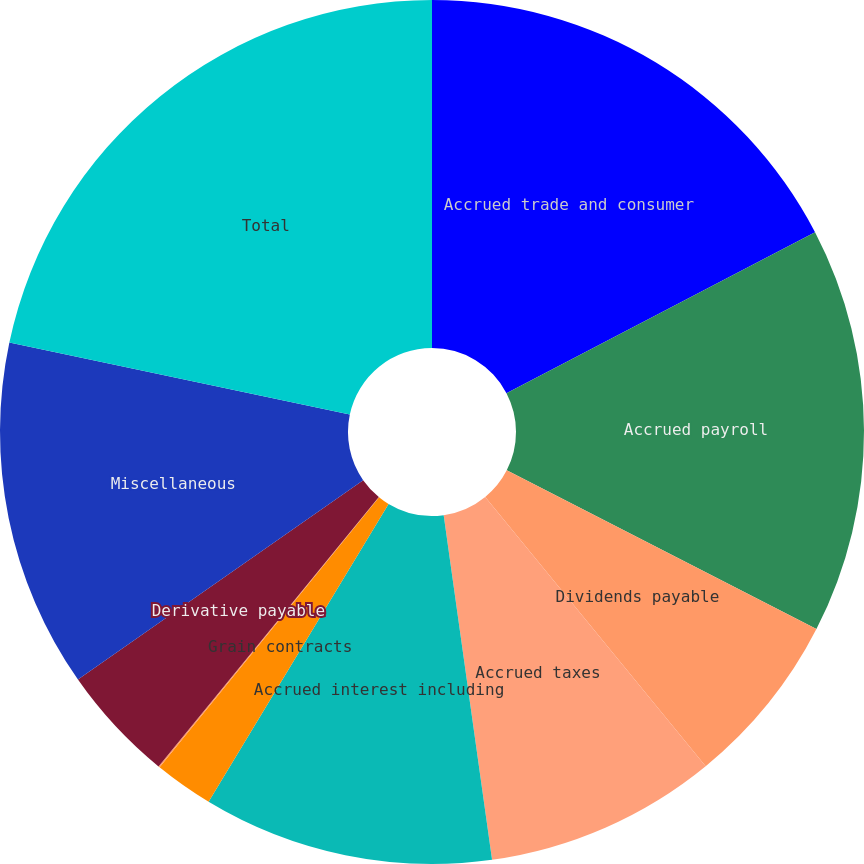Convert chart. <chart><loc_0><loc_0><loc_500><loc_500><pie_chart><fcel>Accrued trade and consumer<fcel>Accrued payroll<fcel>Dividends payable<fcel>Accrued taxes<fcel>Accrued interest including<fcel>Grain contracts<fcel>Restructuring and other exit<fcel>Derivative payable<fcel>Miscellaneous<fcel>Total<nl><fcel>17.35%<fcel>15.19%<fcel>6.54%<fcel>8.7%<fcel>10.87%<fcel>2.21%<fcel>0.05%<fcel>4.38%<fcel>13.03%<fcel>21.68%<nl></chart> 